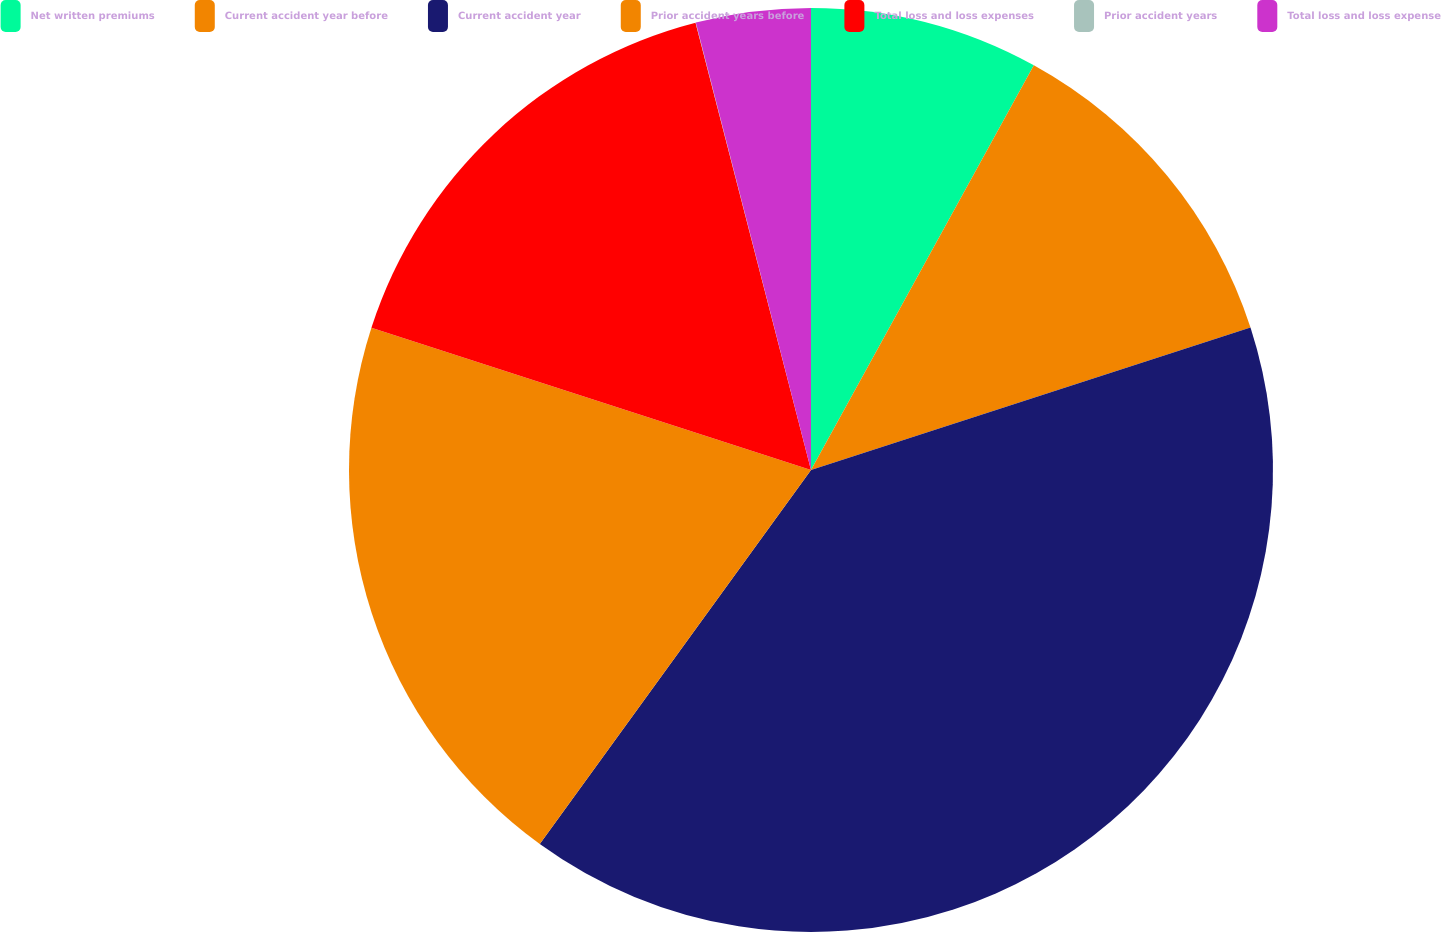Convert chart to OTSL. <chart><loc_0><loc_0><loc_500><loc_500><pie_chart><fcel>Net written premiums<fcel>Current accident year before<fcel>Current accident year<fcel>Prior accident years before<fcel>Total loss and loss expenses<fcel>Prior accident years<fcel>Total loss and loss expense<nl><fcel>8.01%<fcel>12.0%<fcel>39.97%<fcel>19.99%<fcel>16.0%<fcel>0.01%<fcel>4.01%<nl></chart> 